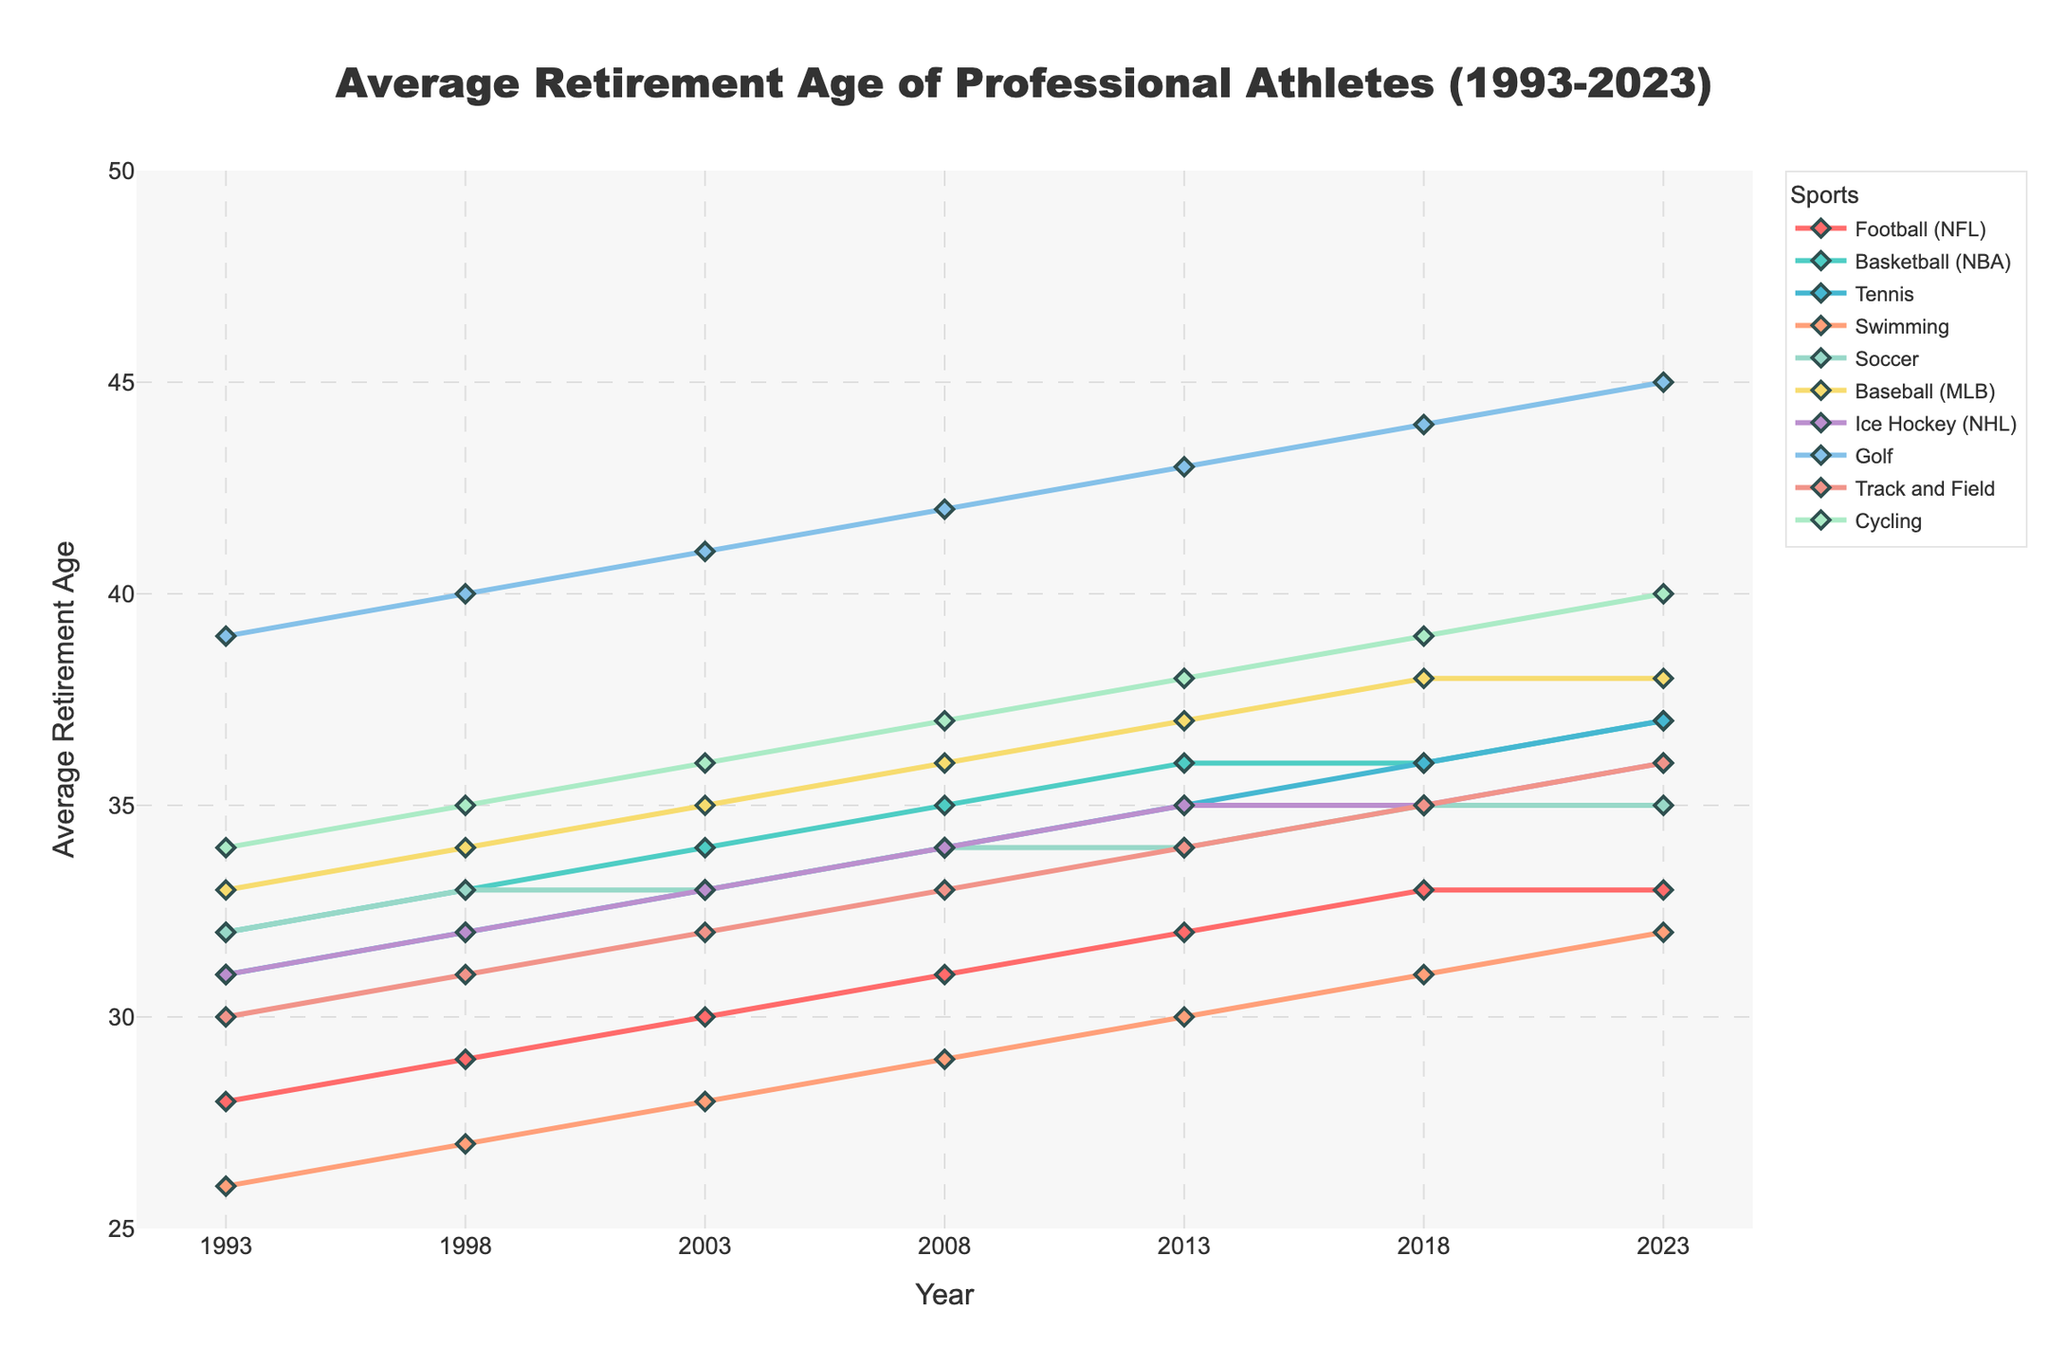What is the average retirement age for Soccer and Ice Hockey in 2023? In 2023, the retirement age for Soccer is 35 and for Ice Hockey is 36. Average these two values: (35 + 36) / 2 = 35.5
Answer: 35.5 Which sport has the greatest increase in retirement age from 1993 to 2023? To find the greatest increase, subtract the 1993 value from the 2023 value for each sport. Football (NFL): 33-28=5, Basketball (NBA): 37-32=5, Tennis: 37-31=6, Swimming: 32-26=6, Soccer: 35-32=3, Baseball (MLB): 38-33=5, Ice Hockey (NHL): 36-31=5, Golf: 45-39=6, Track and Field: 36-30=6, Cycling: 40-34=6. The sports with the greatest increases are Tennis, Swimming, Golf, Track and Field, and Cycling, all with an increase of 6 years
Answer: Tennis, Swimming, Golf, Track and Field, Cycling Between 1993 and 2023, which sport consistently shows the highest retirement age? Evaluate the retirement age for each sport across all years and find the sport with the highest values. Golf consistently has the highest retirement ages across all years.
Answer: Golf What is the total increase in average retirement age for Basketball from 1993 to 2023? Subtract the 1993 value from the 2023 value for Basketball: 37 - 32 = 5.
Answer: 5 By how many years did the average retirement age increase for Swimming from 1993 to 2018? Subtract the 1993 value from the 2018 value for Swimming: 31 - 26 = 5.
Answer: 5 Which sport had the smallest change in retirement age between 2003 and 2023? Calculate the change for each sport: Football (NFL): 33-30=3, Basketball (NBA): 37-34=3, Tennis: 37-33=4, Swimming: 32-28=4, Soccer: 35-33=2, Baseball (MLB): 38-35=3, Ice Hockey (NHL): 36-33=3, Golf: 45-41=4, Track and Field: 36-32=4, Cycling: 40-36=4. Soccer had the smallest change, which is 2 years.
Answer: Soccer Which sports had a retirement age of 34 in the year 2008? Identify the sports with the retirement age of 34 in 2008: Soccer and Ice Hockey.
Answer: Soccer, Ice Hockey From 1993 to 2023, which sport shows a linear consistent increase in retirement age with no plateau or peak? Football (NFL) shows a linear consistent increase in retirement age from 1993 (28) to 2023 (33), as it goes up by roughly one year every five years with no plateau.
Answer: Football (NFL) In 2023, which sports have retirement ages that are greater than 35? Identify the sports with retirement ages greater than 35 in 2023: Basketball (37), Tennis (37), Baseball (38), Golf (45), Track and Field (36), Cycling (40).
Answer: Basketball, Tennis, Baseball, Golf, Track and Field, Cycling 